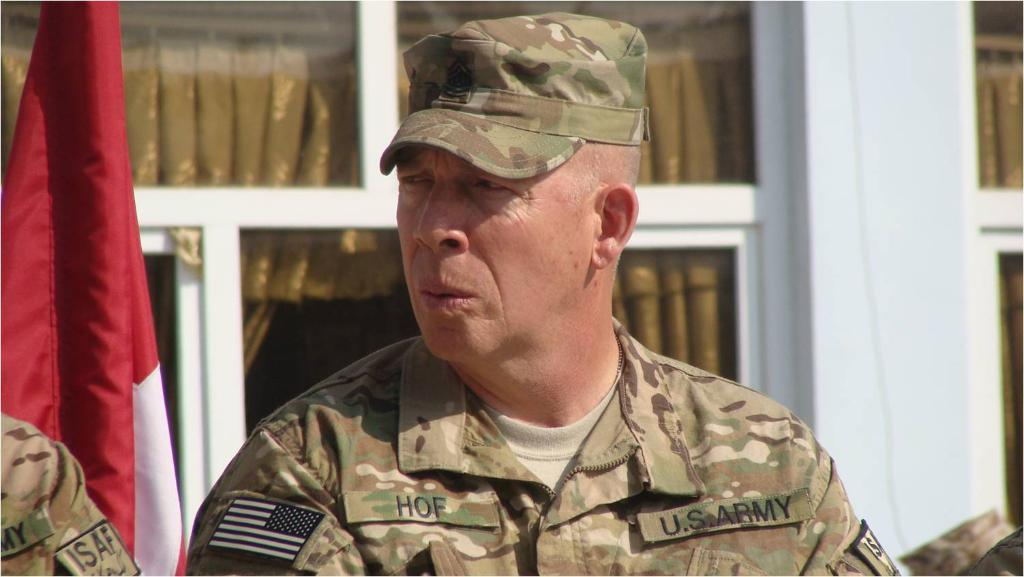Who or what is the main subject in the center of the image? There is a person in the center of the image. What can be seen in the background of the image? There is a flag, windows, a curtain, and a building in the background of the image. How many mice are playing with balls on the mountain in the image? There are no mice or mountains present in the image. 